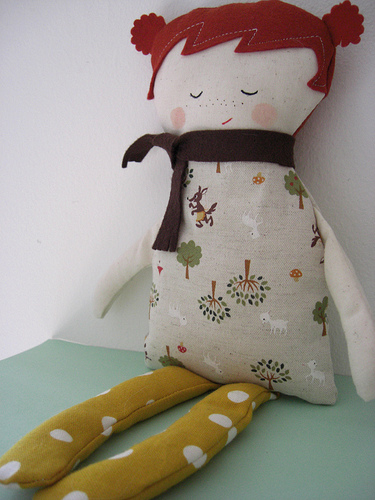<image>
Can you confirm if the wall is above the doll? No. The wall is not positioned above the doll. The vertical arrangement shows a different relationship. 